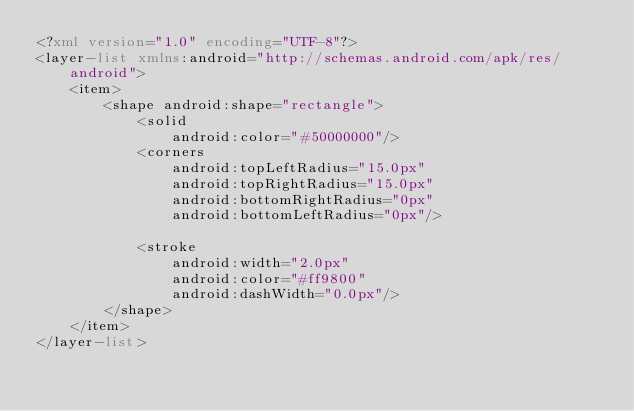<code> <loc_0><loc_0><loc_500><loc_500><_XML_><?xml version="1.0" encoding="UTF-8"?>
<layer-list xmlns:android="http://schemas.android.com/apk/res/android">
	<item>
		<shape android:shape="rectangle">
			<solid
				android:color="#50000000"/>
			<corners 
				android:topLeftRadius="15.0px" 
				android:topRightRadius="15.0px" 
				android:bottomRightRadius="0px" 
				android:bottomLeftRadius="0px"/>

			<stroke 
				android:width="2.0px"
				android:color="#ff9800" 
				android:dashWidth="0.0px"/>
		</shape>
	</item>
</layer-list>
</code> 